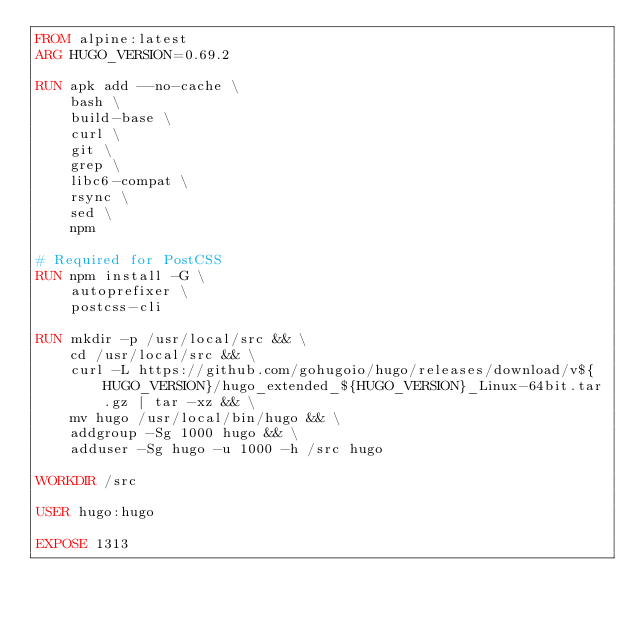<code> <loc_0><loc_0><loc_500><loc_500><_Dockerfile_>FROM alpine:latest
ARG HUGO_VERSION=0.69.2

RUN apk add --no-cache \
    bash \
    build-base \
    curl \
    git \
    grep \
    libc6-compat \
    rsync \
    sed \
    npm

# Required for PostCSS
RUN npm install -G \
    autoprefixer \
    postcss-cli

RUN mkdir -p /usr/local/src && \
    cd /usr/local/src && \
    curl -L https://github.com/gohugoio/hugo/releases/download/v${HUGO_VERSION}/hugo_extended_${HUGO_VERSION}_Linux-64bit.tar.gz | tar -xz && \
    mv hugo /usr/local/bin/hugo && \
    addgroup -Sg 1000 hugo && \
    adduser -Sg hugo -u 1000 -h /src hugo

WORKDIR /src

USER hugo:hugo

EXPOSE 1313</code> 